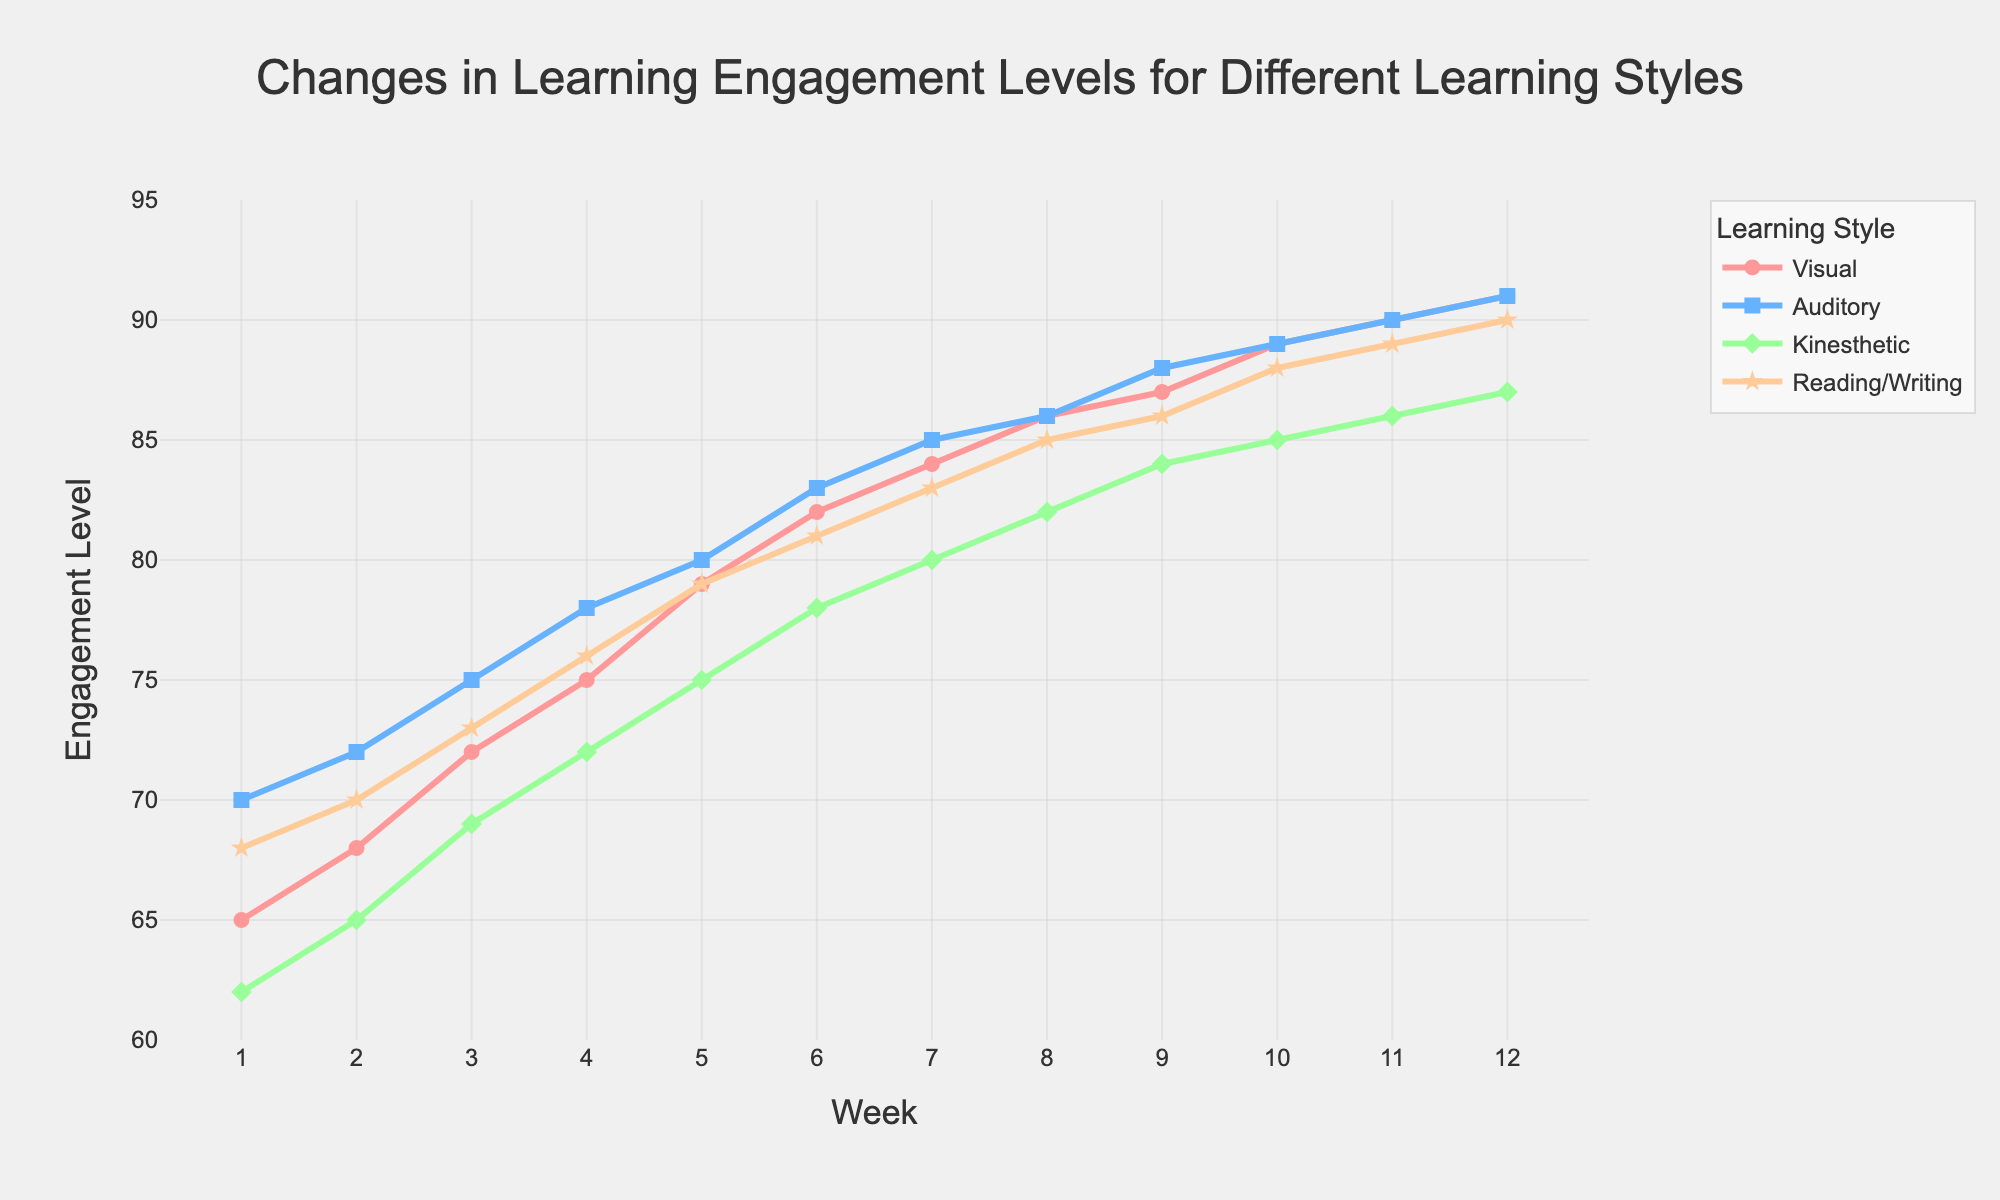What week do Visual Learners reach an engagement level of 90? Look at the line for Visual Learners, which is pink. Identify the week at which this line passes the 90 mark on the y-axis.
Answer: Week 11 Which group had the highest engagement level by Week 5? At Week 5, compare the engagement levels of all groups. The pink line (Visual) is at 79, the blue line (Auditory) is at 80, the green line (Kinesthetic) is at 75, and the orange line (Reading/Writing) is at 79. The highest engagement is recorded by Auditory Learners.
Answer: Auditory Learners How many weeks did it take for Kinesthetic Learners to reach an engagement level of 80? Look at the green line for Kinesthetic Learners. Locate the point at which this line reaches or surpasses the 80 mark, which occurs at Week 7.
Answer: 7 weeks Compare the engagement levels of Visual Learners and Reading/Writing Learners at Week 6. Which group is higher and by how much? At Week 6, the pink line (Visual) is at 82 and the orange line (Reading/Writing) is at 81. Subtract 81 from 82 to find the difference.
Answer: Visual Learners by 1 point What is the average engagement level of Auditory Learners from Week 1 to Week 5? Sum the engagement levels of Auditory Learners from Week 1 to Week 5 (70 + 72 + 75 + 78 + 80), which equals 375. Then, divide by 5 to find the average.
Answer: 75 Which learning style exhibited the most steady increase in engagement over the 12 weeks? Observe the slopes of all four lines. The blue line (Auditory Learners) has a consistently upward trajectory without significant drops or fluctuations.
Answer: Auditory Learners During which week did Reading/Writing Learners reach an engagement level of 85? Look at the orange line for Reading/Writing Learners. Identify the week at which this line reaches the 85 mark, which occurs at Week 8.
Answer: Week 8 Compare the increase in engagement from Week 1 to Week 12 for Kinesthetic Learners and Visual Learners. Which group had a larger increase and by how much? For Kinesthetic Learners (green line), the increase is 87 - 62 = 25. For Visual Learners (pink line), the increase is 91 - 65 = 26. The difference is 26 - 25.
Answer: Visual Learners by 1 point 